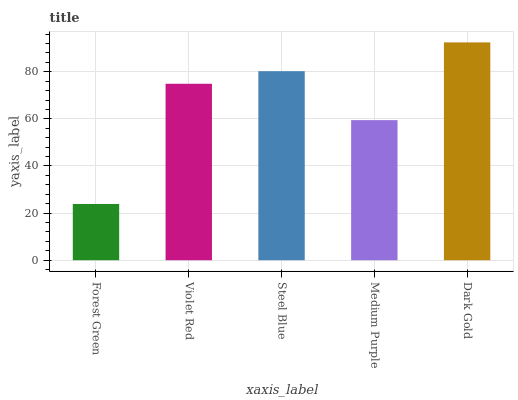Is Forest Green the minimum?
Answer yes or no. Yes. Is Dark Gold the maximum?
Answer yes or no. Yes. Is Violet Red the minimum?
Answer yes or no. No. Is Violet Red the maximum?
Answer yes or no. No. Is Violet Red greater than Forest Green?
Answer yes or no. Yes. Is Forest Green less than Violet Red?
Answer yes or no. Yes. Is Forest Green greater than Violet Red?
Answer yes or no. No. Is Violet Red less than Forest Green?
Answer yes or no. No. Is Violet Red the high median?
Answer yes or no. Yes. Is Violet Red the low median?
Answer yes or no. Yes. Is Dark Gold the high median?
Answer yes or no. No. Is Dark Gold the low median?
Answer yes or no. No. 